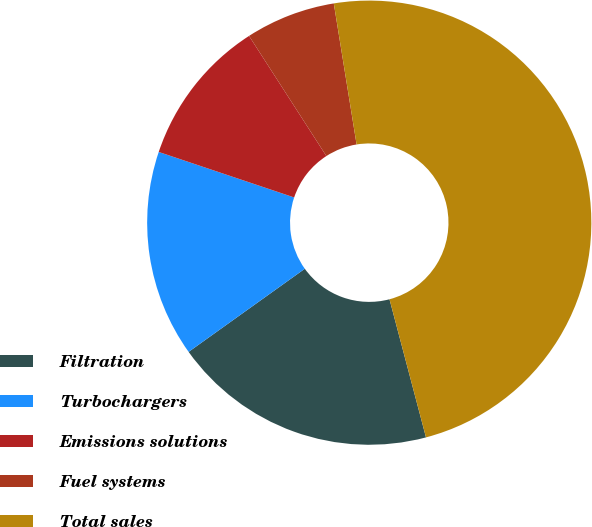Convert chart to OTSL. <chart><loc_0><loc_0><loc_500><loc_500><pie_chart><fcel>Filtration<fcel>Turbochargers<fcel>Emissions solutions<fcel>Fuel systems<fcel>Total sales<nl><fcel>19.23%<fcel>15.04%<fcel>10.74%<fcel>6.55%<fcel>48.44%<nl></chart> 